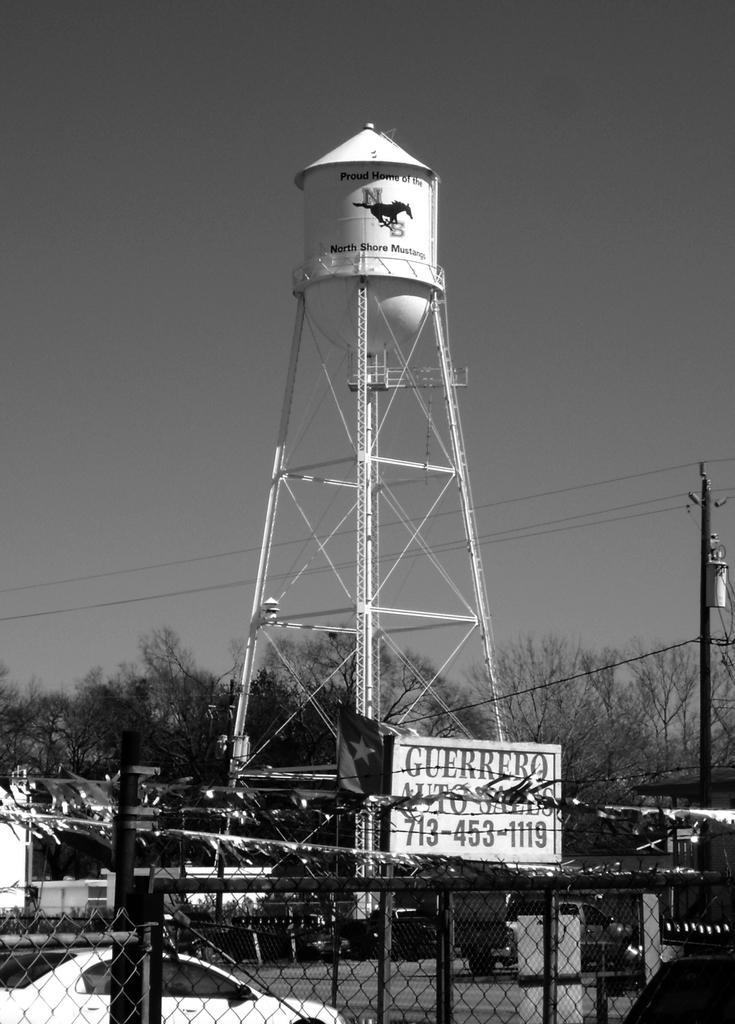In one or two sentences, can you explain what this image depicts? In the picture we can see a fencing and behind it, we can see a car which is white in color and behind it, we can see a tower with a tank on top of it which is white in color and behind it we can see trees and sky. 